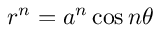Convert formula to latex. <formula><loc_0><loc_0><loc_500><loc_500>r ^ { n } = a ^ { n } \cos n \theta</formula> 